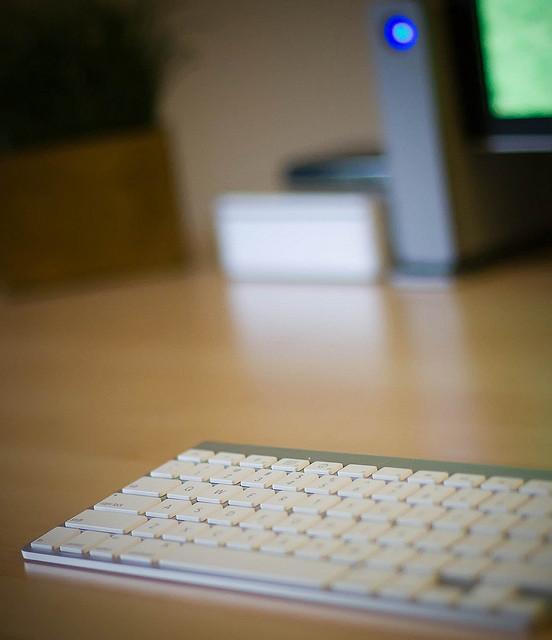Does the keyboard have a mouse?
Be succinct. No. Is that a micro keyboard on the desk?
Short answer required. Yes. What item is closest to the camera?
Quick response, please. Keyboard. What brand of computer goes with this keyboard?
Give a very brief answer. Apple. What is the remote pointing towards?
Keep it brief. No remote. Is there a mouse?
Keep it brief. No. Is this picture blurry?
Answer briefly. Yes. What side of the keyboard is the camera?
Concise answer only. Left. 